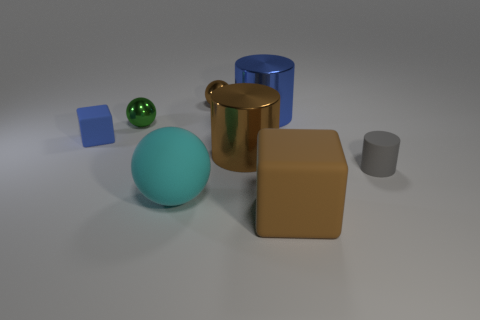There is a tiny metallic thing that is the same color as the big matte block; what shape is it?
Your answer should be very brief. Sphere. There is a large matte object behind the brown matte block; what number of brown matte things are on the right side of it?
Offer a terse response. 1. What number of other tiny balls are the same material as the green sphere?
Give a very brief answer. 1. There is a matte ball; are there any big rubber things right of it?
Keep it short and to the point. Yes. The sphere that is the same size as the brown matte thing is what color?
Offer a very short reply. Cyan. What number of things are either large brown things that are in front of the gray matte cylinder or big cyan matte objects?
Ensure brevity in your answer.  2. How big is the matte object that is both left of the gray cylinder and to the right of the large blue shiny cylinder?
Keep it short and to the point. Large. What is the size of the metal object that is the same color as the tiny rubber block?
Offer a terse response. Large. What number of other objects are the same size as the cyan thing?
Ensure brevity in your answer.  3. There is a cube that is behind the small object on the right side of the big object that is in front of the cyan ball; what color is it?
Give a very brief answer. Blue. 